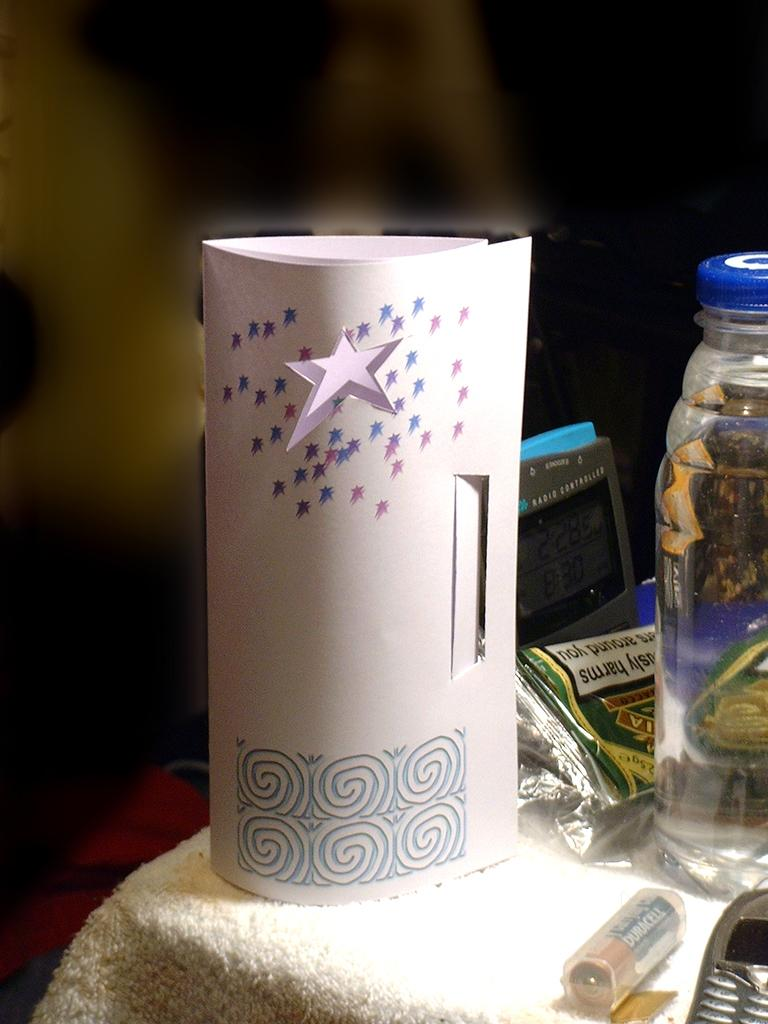What is the main object in the image? There is a decorated paper in the image. What is located beside the decorated paper? There is a cover beside the decorated paper. What other objects can be seen in the image? There is a bottle, a digital clock, a battery, and a cell phone in the image. What type of beam is holding up the church in the image? There is no church or beam present in the image. Are the police visible in the image? No, the police are not visible in the image. 